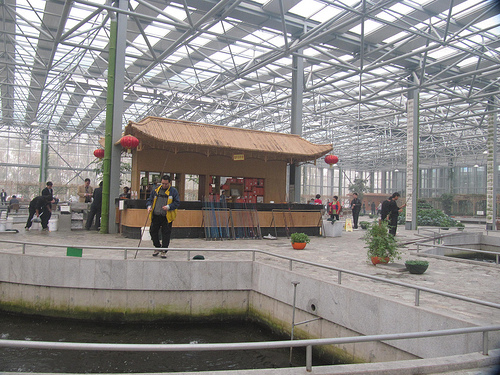<image>
Is the fishing rod on the water? No. The fishing rod is not positioned on the water. They may be near each other, but the fishing rod is not supported by or resting on top of the water. 